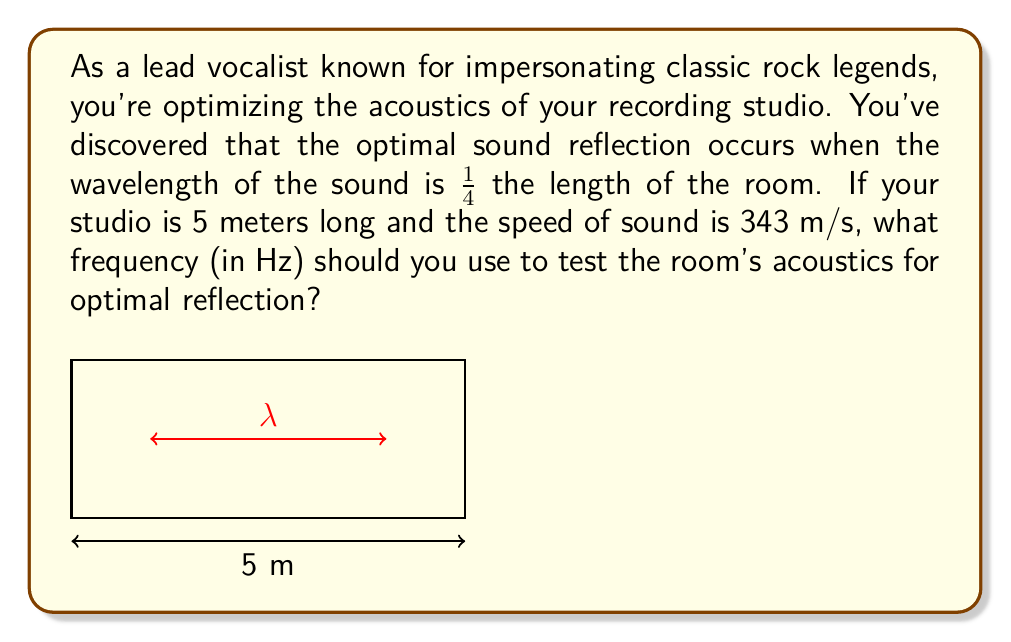Show me your answer to this math problem. Let's approach this step-by-step:

1) We know that the wavelength ($\lambda$) should be 1/4 of the room length:
   $$\lambda = \frac{1}{4} \times 5\text{ m} = 1.25\text{ m}$$

2) The relationship between wavelength ($\lambda$), frequency ($f$), and speed of sound ($v$) is:
   $$v = f\lambda$$

3) We can rearrange this equation to solve for frequency:
   $$f = \frac{v}{\lambda}$$

4) Now, let's substitute our known values:
   $$f = \frac{343\text{ m/s}}{1.25\text{ m}}$$

5) Calculating this:
   $$f = 274.4\text{ Hz}$$

Therefore, the frequency you should use to test the room's acoustics for optimal reflection is approximately 274.4 Hz.
Answer: 274.4 Hz 